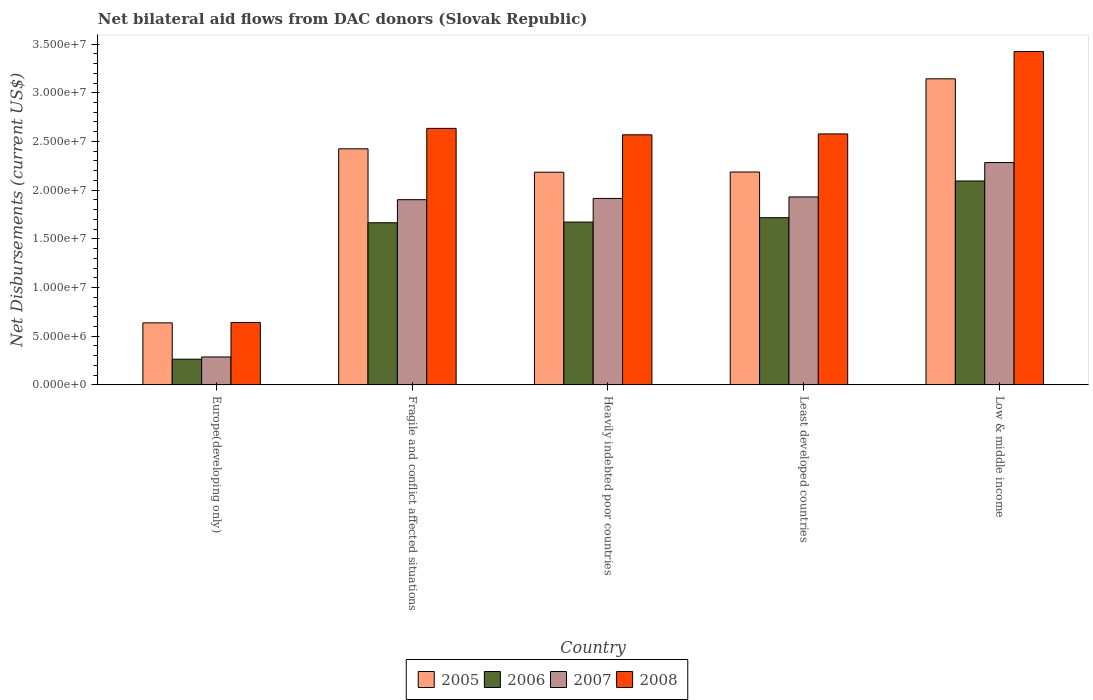How many different coloured bars are there?
Keep it short and to the point. 4. Are the number of bars on each tick of the X-axis equal?
Give a very brief answer. Yes. How many bars are there on the 2nd tick from the left?
Your answer should be very brief. 4. What is the label of the 2nd group of bars from the left?
Make the answer very short. Fragile and conflict affected situations. What is the net bilateral aid flows in 2007 in Europe(developing only)?
Make the answer very short. 2.87e+06. Across all countries, what is the maximum net bilateral aid flows in 2008?
Your response must be concise. 3.42e+07. Across all countries, what is the minimum net bilateral aid flows in 2008?
Ensure brevity in your answer.  6.41e+06. In which country was the net bilateral aid flows in 2005 minimum?
Keep it short and to the point. Europe(developing only). What is the total net bilateral aid flows in 2008 in the graph?
Your answer should be compact. 1.18e+08. What is the difference between the net bilateral aid flows in 2008 in Least developed countries and the net bilateral aid flows in 2006 in Heavily indebted poor countries?
Offer a very short reply. 9.05e+06. What is the average net bilateral aid flows in 2005 per country?
Provide a short and direct response. 2.11e+07. What is the difference between the net bilateral aid flows of/in 2005 and net bilateral aid flows of/in 2008 in Least developed countries?
Make the answer very short. -3.91e+06. In how many countries, is the net bilateral aid flows in 2007 greater than 33000000 US$?
Provide a succinct answer. 0. What is the ratio of the net bilateral aid flows in 2007 in Europe(developing only) to that in Heavily indebted poor countries?
Make the answer very short. 0.15. Is the difference between the net bilateral aid flows in 2005 in Least developed countries and Low & middle income greater than the difference between the net bilateral aid flows in 2008 in Least developed countries and Low & middle income?
Keep it short and to the point. No. What is the difference between the highest and the second highest net bilateral aid flows in 2007?
Provide a short and direct response. 3.68e+06. What is the difference between the highest and the lowest net bilateral aid flows in 2005?
Keep it short and to the point. 2.51e+07. In how many countries, is the net bilateral aid flows in 2007 greater than the average net bilateral aid flows in 2007 taken over all countries?
Your response must be concise. 4. What does the 3rd bar from the left in Low & middle income represents?
Offer a terse response. 2007. What does the 1st bar from the right in Europe(developing only) represents?
Ensure brevity in your answer.  2008. Is it the case that in every country, the sum of the net bilateral aid flows in 2006 and net bilateral aid flows in 2007 is greater than the net bilateral aid flows in 2008?
Ensure brevity in your answer.  No. How many countries are there in the graph?
Offer a very short reply. 5. Does the graph contain grids?
Ensure brevity in your answer.  No. Where does the legend appear in the graph?
Provide a succinct answer. Bottom center. What is the title of the graph?
Your answer should be very brief. Net bilateral aid flows from DAC donors (Slovak Republic). What is the label or title of the Y-axis?
Give a very brief answer. Net Disbursements (current US$). What is the Net Disbursements (current US$) in 2005 in Europe(developing only)?
Give a very brief answer. 6.37e+06. What is the Net Disbursements (current US$) of 2006 in Europe(developing only)?
Make the answer very short. 2.64e+06. What is the Net Disbursements (current US$) of 2007 in Europe(developing only)?
Make the answer very short. 2.87e+06. What is the Net Disbursements (current US$) of 2008 in Europe(developing only)?
Provide a short and direct response. 6.41e+06. What is the Net Disbursements (current US$) in 2005 in Fragile and conflict affected situations?
Keep it short and to the point. 2.42e+07. What is the Net Disbursements (current US$) of 2006 in Fragile and conflict affected situations?
Provide a short and direct response. 1.66e+07. What is the Net Disbursements (current US$) in 2007 in Fragile and conflict affected situations?
Keep it short and to the point. 1.90e+07. What is the Net Disbursements (current US$) of 2008 in Fragile and conflict affected situations?
Offer a very short reply. 2.63e+07. What is the Net Disbursements (current US$) of 2005 in Heavily indebted poor countries?
Provide a short and direct response. 2.18e+07. What is the Net Disbursements (current US$) of 2006 in Heavily indebted poor countries?
Give a very brief answer. 1.67e+07. What is the Net Disbursements (current US$) in 2007 in Heavily indebted poor countries?
Give a very brief answer. 1.92e+07. What is the Net Disbursements (current US$) in 2008 in Heavily indebted poor countries?
Keep it short and to the point. 2.57e+07. What is the Net Disbursements (current US$) of 2005 in Least developed countries?
Your response must be concise. 2.19e+07. What is the Net Disbursements (current US$) of 2006 in Least developed countries?
Your answer should be very brief. 1.72e+07. What is the Net Disbursements (current US$) in 2007 in Least developed countries?
Ensure brevity in your answer.  1.93e+07. What is the Net Disbursements (current US$) in 2008 in Least developed countries?
Provide a short and direct response. 2.58e+07. What is the Net Disbursements (current US$) of 2005 in Low & middle income?
Keep it short and to the point. 3.14e+07. What is the Net Disbursements (current US$) of 2006 in Low & middle income?
Offer a very short reply. 2.09e+07. What is the Net Disbursements (current US$) in 2007 in Low & middle income?
Your answer should be compact. 2.28e+07. What is the Net Disbursements (current US$) in 2008 in Low & middle income?
Your answer should be very brief. 3.42e+07. Across all countries, what is the maximum Net Disbursements (current US$) of 2005?
Provide a succinct answer. 3.14e+07. Across all countries, what is the maximum Net Disbursements (current US$) of 2006?
Your response must be concise. 2.09e+07. Across all countries, what is the maximum Net Disbursements (current US$) of 2007?
Provide a succinct answer. 2.28e+07. Across all countries, what is the maximum Net Disbursements (current US$) of 2008?
Offer a terse response. 3.42e+07. Across all countries, what is the minimum Net Disbursements (current US$) in 2005?
Make the answer very short. 6.37e+06. Across all countries, what is the minimum Net Disbursements (current US$) in 2006?
Your answer should be compact. 2.64e+06. Across all countries, what is the minimum Net Disbursements (current US$) of 2007?
Your answer should be compact. 2.87e+06. Across all countries, what is the minimum Net Disbursements (current US$) of 2008?
Your answer should be compact. 6.41e+06. What is the total Net Disbursements (current US$) of 2005 in the graph?
Give a very brief answer. 1.06e+08. What is the total Net Disbursements (current US$) in 2006 in the graph?
Make the answer very short. 7.41e+07. What is the total Net Disbursements (current US$) of 2007 in the graph?
Give a very brief answer. 8.32e+07. What is the total Net Disbursements (current US$) in 2008 in the graph?
Your answer should be compact. 1.18e+08. What is the difference between the Net Disbursements (current US$) in 2005 in Europe(developing only) and that in Fragile and conflict affected situations?
Your response must be concise. -1.79e+07. What is the difference between the Net Disbursements (current US$) of 2006 in Europe(developing only) and that in Fragile and conflict affected situations?
Keep it short and to the point. -1.40e+07. What is the difference between the Net Disbursements (current US$) of 2007 in Europe(developing only) and that in Fragile and conflict affected situations?
Ensure brevity in your answer.  -1.62e+07. What is the difference between the Net Disbursements (current US$) of 2008 in Europe(developing only) and that in Fragile and conflict affected situations?
Your answer should be very brief. -1.99e+07. What is the difference between the Net Disbursements (current US$) in 2005 in Europe(developing only) and that in Heavily indebted poor countries?
Ensure brevity in your answer.  -1.55e+07. What is the difference between the Net Disbursements (current US$) of 2006 in Europe(developing only) and that in Heavily indebted poor countries?
Keep it short and to the point. -1.41e+07. What is the difference between the Net Disbursements (current US$) in 2007 in Europe(developing only) and that in Heavily indebted poor countries?
Your answer should be very brief. -1.63e+07. What is the difference between the Net Disbursements (current US$) in 2008 in Europe(developing only) and that in Heavily indebted poor countries?
Offer a terse response. -1.93e+07. What is the difference between the Net Disbursements (current US$) of 2005 in Europe(developing only) and that in Least developed countries?
Keep it short and to the point. -1.55e+07. What is the difference between the Net Disbursements (current US$) in 2006 in Europe(developing only) and that in Least developed countries?
Your answer should be compact. -1.45e+07. What is the difference between the Net Disbursements (current US$) of 2007 in Europe(developing only) and that in Least developed countries?
Make the answer very short. -1.64e+07. What is the difference between the Net Disbursements (current US$) in 2008 in Europe(developing only) and that in Least developed countries?
Provide a succinct answer. -1.94e+07. What is the difference between the Net Disbursements (current US$) of 2005 in Europe(developing only) and that in Low & middle income?
Your answer should be very brief. -2.51e+07. What is the difference between the Net Disbursements (current US$) of 2006 in Europe(developing only) and that in Low & middle income?
Offer a very short reply. -1.83e+07. What is the difference between the Net Disbursements (current US$) of 2007 in Europe(developing only) and that in Low & middle income?
Make the answer very short. -2.00e+07. What is the difference between the Net Disbursements (current US$) of 2008 in Europe(developing only) and that in Low & middle income?
Your answer should be very brief. -2.78e+07. What is the difference between the Net Disbursements (current US$) in 2005 in Fragile and conflict affected situations and that in Heavily indebted poor countries?
Provide a short and direct response. 2.40e+06. What is the difference between the Net Disbursements (current US$) in 2007 in Fragile and conflict affected situations and that in Heavily indebted poor countries?
Provide a short and direct response. -1.30e+05. What is the difference between the Net Disbursements (current US$) in 2005 in Fragile and conflict affected situations and that in Least developed countries?
Offer a very short reply. 2.38e+06. What is the difference between the Net Disbursements (current US$) in 2006 in Fragile and conflict affected situations and that in Least developed countries?
Give a very brief answer. -5.20e+05. What is the difference between the Net Disbursements (current US$) in 2007 in Fragile and conflict affected situations and that in Least developed countries?
Give a very brief answer. -2.80e+05. What is the difference between the Net Disbursements (current US$) in 2008 in Fragile and conflict affected situations and that in Least developed countries?
Ensure brevity in your answer.  5.70e+05. What is the difference between the Net Disbursements (current US$) of 2005 in Fragile and conflict affected situations and that in Low & middle income?
Your answer should be very brief. -7.19e+06. What is the difference between the Net Disbursements (current US$) in 2006 in Fragile and conflict affected situations and that in Low & middle income?
Provide a short and direct response. -4.29e+06. What is the difference between the Net Disbursements (current US$) of 2007 in Fragile and conflict affected situations and that in Low & middle income?
Your answer should be compact. -3.81e+06. What is the difference between the Net Disbursements (current US$) in 2008 in Fragile and conflict affected situations and that in Low & middle income?
Offer a very short reply. -7.89e+06. What is the difference between the Net Disbursements (current US$) of 2006 in Heavily indebted poor countries and that in Least developed countries?
Ensure brevity in your answer.  -4.50e+05. What is the difference between the Net Disbursements (current US$) in 2005 in Heavily indebted poor countries and that in Low & middle income?
Your answer should be compact. -9.59e+06. What is the difference between the Net Disbursements (current US$) of 2006 in Heavily indebted poor countries and that in Low & middle income?
Give a very brief answer. -4.22e+06. What is the difference between the Net Disbursements (current US$) of 2007 in Heavily indebted poor countries and that in Low & middle income?
Give a very brief answer. -3.68e+06. What is the difference between the Net Disbursements (current US$) in 2008 in Heavily indebted poor countries and that in Low & middle income?
Provide a succinct answer. -8.55e+06. What is the difference between the Net Disbursements (current US$) of 2005 in Least developed countries and that in Low & middle income?
Provide a succinct answer. -9.57e+06. What is the difference between the Net Disbursements (current US$) in 2006 in Least developed countries and that in Low & middle income?
Your response must be concise. -3.77e+06. What is the difference between the Net Disbursements (current US$) of 2007 in Least developed countries and that in Low & middle income?
Your answer should be compact. -3.53e+06. What is the difference between the Net Disbursements (current US$) of 2008 in Least developed countries and that in Low & middle income?
Provide a short and direct response. -8.46e+06. What is the difference between the Net Disbursements (current US$) of 2005 in Europe(developing only) and the Net Disbursements (current US$) of 2006 in Fragile and conflict affected situations?
Keep it short and to the point. -1.03e+07. What is the difference between the Net Disbursements (current US$) of 2005 in Europe(developing only) and the Net Disbursements (current US$) of 2007 in Fragile and conflict affected situations?
Your response must be concise. -1.26e+07. What is the difference between the Net Disbursements (current US$) of 2005 in Europe(developing only) and the Net Disbursements (current US$) of 2008 in Fragile and conflict affected situations?
Make the answer very short. -2.00e+07. What is the difference between the Net Disbursements (current US$) in 2006 in Europe(developing only) and the Net Disbursements (current US$) in 2007 in Fragile and conflict affected situations?
Offer a very short reply. -1.64e+07. What is the difference between the Net Disbursements (current US$) in 2006 in Europe(developing only) and the Net Disbursements (current US$) in 2008 in Fragile and conflict affected situations?
Your response must be concise. -2.37e+07. What is the difference between the Net Disbursements (current US$) of 2007 in Europe(developing only) and the Net Disbursements (current US$) of 2008 in Fragile and conflict affected situations?
Give a very brief answer. -2.35e+07. What is the difference between the Net Disbursements (current US$) of 2005 in Europe(developing only) and the Net Disbursements (current US$) of 2006 in Heavily indebted poor countries?
Provide a succinct answer. -1.04e+07. What is the difference between the Net Disbursements (current US$) of 2005 in Europe(developing only) and the Net Disbursements (current US$) of 2007 in Heavily indebted poor countries?
Your answer should be compact. -1.28e+07. What is the difference between the Net Disbursements (current US$) of 2005 in Europe(developing only) and the Net Disbursements (current US$) of 2008 in Heavily indebted poor countries?
Ensure brevity in your answer.  -1.93e+07. What is the difference between the Net Disbursements (current US$) in 2006 in Europe(developing only) and the Net Disbursements (current US$) in 2007 in Heavily indebted poor countries?
Your answer should be compact. -1.65e+07. What is the difference between the Net Disbursements (current US$) of 2006 in Europe(developing only) and the Net Disbursements (current US$) of 2008 in Heavily indebted poor countries?
Offer a terse response. -2.30e+07. What is the difference between the Net Disbursements (current US$) of 2007 in Europe(developing only) and the Net Disbursements (current US$) of 2008 in Heavily indebted poor countries?
Provide a short and direct response. -2.28e+07. What is the difference between the Net Disbursements (current US$) of 2005 in Europe(developing only) and the Net Disbursements (current US$) of 2006 in Least developed countries?
Provide a short and direct response. -1.08e+07. What is the difference between the Net Disbursements (current US$) of 2005 in Europe(developing only) and the Net Disbursements (current US$) of 2007 in Least developed countries?
Ensure brevity in your answer.  -1.29e+07. What is the difference between the Net Disbursements (current US$) of 2005 in Europe(developing only) and the Net Disbursements (current US$) of 2008 in Least developed countries?
Your answer should be very brief. -1.94e+07. What is the difference between the Net Disbursements (current US$) in 2006 in Europe(developing only) and the Net Disbursements (current US$) in 2007 in Least developed countries?
Provide a succinct answer. -1.67e+07. What is the difference between the Net Disbursements (current US$) of 2006 in Europe(developing only) and the Net Disbursements (current US$) of 2008 in Least developed countries?
Provide a succinct answer. -2.31e+07. What is the difference between the Net Disbursements (current US$) of 2007 in Europe(developing only) and the Net Disbursements (current US$) of 2008 in Least developed countries?
Ensure brevity in your answer.  -2.29e+07. What is the difference between the Net Disbursements (current US$) of 2005 in Europe(developing only) and the Net Disbursements (current US$) of 2006 in Low & middle income?
Your answer should be very brief. -1.46e+07. What is the difference between the Net Disbursements (current US$) of 2005 in Europe(developing only) and the Net Disbursements (current US$) of 2007 in Low & middle income?
Make the answer very short. -1.65e+07. What is the difference between the Net Disbursements (current US$) in 2005 in Europe(developing only) and the Net Disbursements (current US$) in 2008 in Low & middle income?
Make the answer very short. -2.79e+07. What is the difference between the Net Disbursements (current US$) of 2006 in Europe(developing only) and the Net Disbursements (current US$) of 2007 in Low & middle income?
Make the answer very short. -2.02e+07. What is the difference between the Net Disbursements (current US$) of 2006 in Europe(developing only) and the Net Disbursements (current US$) of 2008 in Low & middle income?
Your answer should be very brief. -3.16e+07. What is the difference between the Net Disbursements (current US$) of 2007 in Europe(developing only) and the Net Disbursements (current US$) of 2008 in Low & middle income?
Give a very brief answer. -3.14e+07. What is the difference between the Net Disbursements (current US$) in 2005 in Fragile and conflict affected situations and the Net Disbursements (current US$) in 2006 in Heavily indebted poor countries?
Offer a terse response. 7.52e+06. What is the difference between the Net Disbursements (current US$) in 2005 in Fragile and conflict affected situations and the Net Disbursements (current US$) in 2007 in Heavily indebted poor countries?
Your answer should be very brief. 5.09e+06. What is the difference between the Net Disbursements (current US$) in 2005 in Fragile and conflict affected situations and the Net Disbursements (current US$) in 2008 in Heavily indebted poor countries?
Provide a succinct answer. -1.44e+06. What is the difference between the Net Disbursements (current US$) of 2006 in Fragile and conflict affected situations and the Net Disbursements (current US$) of 2007 in Heavily indebted poor countries?
Make the answer very short. -2.50e+06. What is the difference between the Net Disbursements (current US$) of 2006 in Fragile and conflict affected situations and the Net Disbursements (current US$) of 2008 in Heavily indebted poor countries?
Ensure brevity in your answer.  -9.03e+06. What is the difference between the Net Disbursements (current US$) of 2007 in Fragile and conflict affected situations and the Net Disbursements (current US$) of 2008 in Heavily indebted poor countries?
Your answer should be compact. -6.66e+06. What is the difference between the Net Disbursements (current US$) of 2005 in Fragile and conflict affected situations and the Net Disbursements (current US$) of 2006 in Least developed countries?
Provide a succinct answer. 7.07e+06. What is the difference between the Net Disbursements (current US$) of 2005 in Fragile and conflict affected situations and the Net Disbursements (current US$) of 2007 in Least developed countries?
Provide a succinct answer. 4.94e+06. What is the difference between the Net Disbursements (current US$) of 2005 in Fragile and conflict affected situations and the Net Disbursements (current US$) of 2008 in Least developed countries?
Offer a very short reply. -1.53e+06. What is the difference between the Net Disbursements (current US$) of 2006 in Fragile and conflict affected situations and the Net Disbursements (current US$) of 2007 in Least developed countries?
Your response must be concise. -2.65e+06. What is the difference between the Net Disbursements (current US$) in 2006 in Fragile and conflict affected situations and the Net Disbursements (current US$) in 2008 in Least developed countries?
Give a very brief answer. -9.12e+06. What is the difference between the Net Disbursements (current US$) of 2007 in Fragile and conflict affected situations and the Net Disbursements (current US$) of 2008 in Least developed countries?
Your answer should be compact. -6.75e+06. What is the difference between the Net Disbursements (current US$) of 2005 in Fragile and conflict affected situations and the Net Disbursements (current US$) of 2006 in Low & middle income?
Your answer should be compact. 3.30e+06. What is the difference between the Net Disbursements (current US$) in 2005 in Fragile and conflict affected situations and the Net Disbursements (current US$) in 2007 in Low & middle income?
Provide a short and direct response. 1.41e+06. What is the difference between the Net Disbursements (current US$) of 2005 in Fragile and conflict affected situations and the Net Disbursements (current US$) of 2008 in Low & middle income?
Ensure brevity in your answer.  -9.99e+06. What is the difference between the Net Disbursements (current US$) in 2006 in Fragile and conflict affected situations and the Net Disbursements (current US$) in 2007 in Low & middle income?
Your answer should be very brief. -6.18e+06. What is the difference between the Net Disbursements (current US$) in 2006 in Fragile and conflict affected situations and the Net Disbursements (current US$) in 2008 in Low & middle income?
Give a very brief answer. -1.76e+07. What is the difference between the Net Disbursements (current US$) in 2007 in Fragile and conflict affected situations and the Net Disbursements (current US$) in 2008 in Low & middle income?
Offer a very short reply. -1.52e+07. What is the difference between the Net Disbursements (current US$) in 2005 in Heavily indebted poor countries and the Net Disbursements (current US$) in 2006 in Least developed countries?
Offer a very short reply. 4.67e+06. What is the difference between the Net Disbursements (current US$) in 2005 in Heavily indebted poor countries and the Net Disbursements (current US$) in 2007 in Least developed countries?
Keep it short and to the point. 2.54e+06. What is the difference between the Net Disbursements (current US$) in 2005 in Heavily indebted poor countries and the Net Disbursements (current US$) in 2008 in Least developed countries?
Give a very brief answer. -3.93e+06. What is the difference between the Net Disbursements (current US$) in 2006 in Heavily indebted poor countries and the Net Disbursements (current US$) in 2007 in Least developed countries?
Provide a short and direct response. -2.58e+06. What is the difference between the Net Disbursements (current US$) in 2006 in Heavily indebted poor countries and the Net Disbursements (current US$) in 2008 in Least developed countries?
Provide a short and direct response. -9.05e+06. What is the difference between the Net Disbursements (current US$) of 2007 in Heavily indebted poor countries and the Net Disbursements (current US$) of 2008 in Least developed countries?
Your answer should be compact. -6.62e+06. What is the difference between the Net Disbursements (current US$) in 2005 in Heavily indebted poor countries and the Net Disbursements (current US$) in 2006 in Low & middle income?
Give a very brief answer. 9.00e+05. What is the difference between the Net Disbursements (current US$) of 2005 in Heavily indebted poor countries and the Net Disbursements (current US$) of 2007 in Low & middle income?
Your response must be concise. -9.90e+05. What is the difference between the Net Disbursements (current US$) of 2005 in Heavily indebted poor countries and the Net Disbursements (current US$) of 2008 in Low & middle income?
Your response must be concise. -1.24e+07. What is the difference between the Net Disbursements (current US$) of 2006 in Heavily indebted poor countries and the Net Disbursements (current US$) of 2007 in Low & middle income?
Provide a succinct answer. -6.11e+06. What is the difference between the Net Disbursements (current US$) of 2006 in Heavily indebted poor countries and the Net Disbursements (current US$) of 2008 in Low & middle income?
Give a very brief answer. -1.75e+07. What is the difference between the Net Disbursements (current US$) of 2007 in Heavily indebted poor countries and the Net Disbursements (current US$) of 2008 in Low & middle income?
Provide a short and direct response. -1.51e+07. What is the difference between the Net Disbursements (current US$) of 2005 in Least developed countries and the Net Disbursements (current US$) of 2006 in Low & middle income?
Provide a succinct answer. 9.20e+05. What is the difference between the Net Disbursements (current US$) of 2005 in Least developed countries and the Net Disbursements (current US$) of 2007 in Low & middle income?
Ensure brevity in your answer.  -9.70e+05. What is the difference between the Net Disbursements (current US$) in 2005 in Least developed countries and the Net Disbursements (current US$) in 2008 in Low & middle income?
Make the answer very short. -1.24e+07. What is the difference between the Net Disbursements (current US$) of 2006 in Least developed countries and the Net Disbursements (current US$) of 2007 in Low & middle income?
Give a very brief answer. -5.66e+06. What is the difference between the Net Disbursements (current US$) of 2006 in Least developed countries and the Net Disbursements (current US$) of 2008 in Low & middle income?
Your response must be concise. -1.71e+07. What is the difference between the Net Disbursements (current US$) in 2007 in Least developed countries and the Net Disbursements (current US$) in 2008 in Low & middle income?
Make the answer very short. -1.49e+07. What is the average Net Disbursements (current US$) of 2005 per country?
Your answer should be compact. 2.11e+07. What is the average Net Disbursements (current US$) of 2006 per country?
Ensure brevity in your answer.  1.48e+07. What is the average Net Disbursements (current US$) in 2007 per country?
Give a very brief answer. 1.66e+07. What is the average Net Disbursements (current US$) of 2008 per country?
Your answer should be very brief. 2.37e+07. What is the difference between the Net Disbursements (current US$) of 2005 and Net Disbursements (current US$) of 2006 in Europe(developing only)?
Your response must be concise. 3.73e+06. What is the difference between the Net Disbursements (current US$) in 2005 and Net Disbursements (current US$) in 2007 in Europe(developing only)?
Provide a short and direct response. 3.50e+06. What is the difference between the Net Disbursements (current US$) of 2006 and Net Disbursements (current US$) of 2008 in Europe(developing only)?
Your answer should be compact. -3.77e+06. What is the difference between the Net Disbursements (current US$) in 2007 and Net Disbursements (current US$) in 2008 in Europe(developing only)?
Your response must be concise. -3.54e+06. What is the difference between the Net Disbursements (current US$) in 2005 and Net Disbursements (current US$) in 2006 in Fragile and conflict affected situations?
Provide a short and direct response. 7.59e+06. What is the difference between the Net Disbursements (current US$) in 2005 and Net Disbursements (current US$) in 2007 in Fragile and conflict affected situations?
Offer a very short reply. 5.22e+06. What is the difference between the Net Disbursements (current US$) of 2005 and Net Disbursements (current US$) of 2008 in Fragile and conflict affected situations?
Your answer should be very brief. -2.10e+06. What is the difference between the Net Disbursements (current US$) of 2006 and Net Disbursements (current US$) of 2007 in Fragile and conflict affected situations?
Keep it short and to the point. -2.37e+06. What is the difference between the Net Disbursements (current US$) of 2006 and Net Disbursements (current US$) of 2008 in Fragile and conflict affected situations?
Ensure brevity in your answer.  -9.69e+06. What is the difference between the Net Disbursements (current US$) in 2007 and Net Disbursements (current US$) in 2008 in Fragile and conflict affected situations?
Your response must be concise. -7.32e+06. What is the difference between the Net Disbursements (current US$) of 2005 and Net Disbursements (current US$) of 2006 in Heavily indebted poor countries?
Your answer should be compact. 5.12e+06. What is the difference between the Net Disbursements (current US$) in 2005 and Net Disbursements (current US$) in 2007 in Heavily indebted poor countries?
Your response must be concise. 2.69e+06. What is the difference between the Net Disbursements (current US$) of 2005 and Net Disbursements (current US$) of 2008 in Heavily indebted poor countries?
Your answer should be compact. -3.84e+06. What is the difference between the Net Disbursements (current US$) in 2006 and Net Disbursements (current US$) in 2007 in Heavily indebted poor countries?
Make the answer very short. -2.43e+06. What is the difference between the Net Disbursements (current US$) in 2006 and Net Disbursements (current US$) in 2008 in Heavily indebted poor countries?
Keep it short and to the point. -8.96e+06. What is the difference between the Net Disbursements (current US$) in 2007 and Net Disbursements (current US$) in 2008 in Heavily indebted poor countries?
Provide a short and direct response. -6.53e+06. What is the difference between the Net Disbursements (current US$) of 2005 and Net Disbursements (current US$) of 2006 in Least developed countries?
Provide a short and direct response. 4.69e+06. What is the difference between the Net Disbursements (current US$) in 2005 and Net Disbursements (current US$) in 2007 in Least developed countries?
Offer a terse response. 2.56e+06. What is the difference between the Net Disbursements (current US$) in 2005 and Net Disbursements (current US$) in 2008 in Least developed countries?
Provide a short and direct response. -3.91e+06. What is the difference between the Net Disbursements (current US$) in 2006 and Net Disbursements (current US$) in 2007 in Least developed countries?
Your answer should be compact. -2.13e+06. What is the difference between the Net Disbursements (current US$) of 2006 and Net Disbursements (current US$) of 2008 in Least developed countries?
Provide a short and direct response. -8.60e+06. What is the difference between the Net Disbursements (current US$) of 2007 and Net Disbursements (current US$) of 2008 in Least developed countries?
Offer a very short reply. -6.47e+06. What is the difference between the Net Disbursements (current US$) in 2005 and Net Disbursements (current US$) in 2006 in Low & middle income?
Your answer should be very brief. 1.05e+07. What is the difference between the Net Disbursements (current US$) of 2005 and Net Disbursements (current US$) of 2007 in Low & middle income?
Provide a short and direct response. 8.60e+06. What is the difference between the Net Disbursements (current US$) of 2005 and Net Disbursements (current US$) of 2008 in Low & middle income?
Make the answer very short. -2.80e+06. What is the difference between the Net Disbursements (current US$) of 2006 and Net Disbursements (current US$) of 2007 in Low & middle income?
Offer a terse response. -1.89e+06. What is the difference between the Net Disbursements (current US$) of 2006 and Net Disbursements (current US$) of 2008 in Low & middle income?
Offer a very short reply. -1.33e+07. What is the difference between the Net Disbursements (current US$) in 2007 and Net Disbursements (current US$) in 2008 in Low & middle income?
Ensure brevity in your answer.  -1.14e+07. What is the ratio of the Net Disbursements (current US$) of 2005 in Europe(developing only) to that in Fragile and conflict affected situations?
Keep it short and to the point. 0.26. What is the ratio of the Net Disbursements (current US$) of 2006 in Europe(developing only) to that in Fragile and conflict affected situations?
Your response must be concise. 0.16. What is the ratio of the Net Disbursements (current US$) in 2007 in Europe(developing only) to that in Fragile and conflict affected situations?
Provide a short and direct response. 0.15. What is the ratio of the Net Disbursements (current US$) in 2008 in Europe(developing only) to that in Fragile and conflict affected situations?
Your answer should be very brief. 0.24. What is the ratio of the Net Disbursements (current US$) in 2005 in Europe(developing only) to that in Heavily indebted poor countries?
Make the answer very short. 0.29. What is the ratio of the Net Disbursements (current US$) of 2006 in Europe(developing only) to that in Heavily indebted poor countries?
Your response must be concise. 0.16. What is the ratio of the Net Disbursements (current US$) of 2007 in Europe(developing only) to that in Heavily indebted poor countries?
Keep it short and to the point. 0.15. What is the ratio of the Net Disbursements (current US$) in 2008 in Europe(developing only) to that in Heavily indebted poor countries?
Your answer should be compact. 0.25. What is the ratio of the Net Disbursements (current US$) of 2005 in Europe(developing only) to that in Least developed countries?
Keep it short and to the point. 0.29. What is the ratio of the Net Disbursements (current US$) of 2006 in Europe(developing only) to that in Least developed countries?
Provide a short and direct response. 0.15. What is the ratio of the Net Disbursements (current US$) of 2007 in Europe(developing only) to that in Least developed countries?
Offer a terse response. 0.15. What is the ratio of the Net Disbursements (current US$) of 2008 in Europe(developing only) to that in Least developed countries?
Ensure brevity in your answer.  0.25. What is the ratio of the Net Disbursements (current US$) of 2005 in Europe(developing only) to that in Low & middle income?
Provide a succinct answer. 0.2. What is the ratio of the Net Disbursements (current US$) of 2006 in Europe(developing only) to that in Low & middle income?
Ensure brevity in your answer.  0.13. What is the ratio of the Net Disbursements (current US$) in 2007 in Europe(developing only) to that in Low & middle income?
Your response must be concise. 0.13. What is the ratio of the Net Disbursements (current US$) of 2008 in Europe(developing only) to that in Low & middle income?
Provide a succinct answer. 0.19. What is the ratio of the Net Disbursements (current US$) in 2005 in Fragile and conflict affected situations to that in Heavily indebted poor countries?
Provide a succinct answer. 1.11. What is the ratio of the Net Disbursements (current US$) of 2008 in Fragile and conflict affected situations to that in Heavily indebted poor countries?
Provide a short and direct response. 1.03. What is the ratio of the Net Disbursements (current US$) in 2005 in Fragile and conflict affected situations to that in Least developed countries?
Provide a short and direct response. 1.11. What is the ratio of the Net Disbursements (current US$) of 2006 in Fragile and conflict affected situations to that in Least developed countries?
Make the answer very short. 0.97. What is the ratio of the Net Disbursements (current US$) of 2007 in Fragile and conflict affected situations to that in Least developed countries?
Your answer should be compact. 0.99. What is the ratio of the Net Disbursements (current US$) in 2008 in Fragile and conflict affected situations to that in Least developed countries?
Keep it short and to the point. 1.02. What is the ratio of the Net Disbursements (current US$) of 2005 in Fragile and conflict affected situations to that in Low & middle income?
Give a very brief answer. 0.77. What is the ratio of the Net Disbursements (current US$) of 2006 in Fragile and conflict affected situations to that in Low & middle income?
Provide a succinct answer. 0.8. What is the ratio of the Net Disbursements (current US$) in 2007 in Fragile and conflict affected situations to that in Low & middle income?
Offer a very short reply. 0.83. What is the ratio of the Net Disbursements (current US$) of 2008 in Fragile and conflict affected situations to that in Low & middle income?
Your answer should be compact. 0.77. What is the ratio of the Net Disbursements (current US$) in 2006 in Heavily indebted poor countries to that in Least developed countries?
Your answer should be very brief. 0.97. What is the ratio of the Net Disbursements (current US$) of 2008 in Heavily indebted poor countries to that in Least developed countries?
Keep it short and to the point. 1. What is the ratio of the Net Disbursements (current US$) in 2005 in Heavily indebted poor countries to that in Low & middle income?
Offer a very short reply. 0.69. What is the ratio of the Net Disbursements (current US$) in 2006 in Heavily indebted poor countries to that in Low & middle income?
Ensure brevity in your answer.  0.8. What is the ratio of the Net Disbursements (current US$) of 2007 in Heavily indebted poor countries to that in Low & middle income?
Provide a succinct answer. 0.84. What is the ratio of the Net Disbursements (current US$) in 2008 in Heavily indebted poor countries to that in Low & middle income?
Your answer should be compact. 0.75. What is the ratio of the Net Disbursements (current US$) of 2005 in Least developed countries to that in Low & middle income?
Give a very brief answer. 0.7. What is the ratio of the Net Disbursements (current US$) in 2006 in Least developed countries to that in Low & middle income?
Provide a short and direct response. 0.82. What is the ratio of the Net Disbursements (current US$) of 2007 in Least developed countries to that in Low & middle income?
Your response must be concise. 0.85. What is the ratio of the Net Disbursements (current US$) in 2008 in Least developed countries to that in Low & middle income?
Make the answer very short. 0.75. What is the difference between the highest and the second highest Net Disbursements (current US$) in 2005?
Provide a short and direct response. 7.19e+06. What is the difference between the highest and the second highest Net Disbursements (current US$) in 2006?
Make the answer very short. 3.77e+06. What is the difference between the highest and the second highest Net Disbursements (current US$) in 2007?
Ensure brevity in your answer.  3.53e+06. What is the difference between the highest and the second highest Net Disbursements (current US$) in 2008?
Your response must be concise. 7.89e+06. What is the difference between the highest and the lowest Net Disbursements (current US$) of 2005?
Ensure brevity in your answer.  2.51e+07. What is the difference between the highest and the lowest Net Disbursements (current US$) of 2006?
Your answer should be compact. 1.83e+07. What is the difference between the highest and the lowest Net Disbursements (current US$) in 2007?
Provide a short and direct response. 2.00e+07. What is the difference between the highest and the lowest Net Disbursements (current US$) of 2008?
Ensure brevity in your answer.  2.78e+07. 